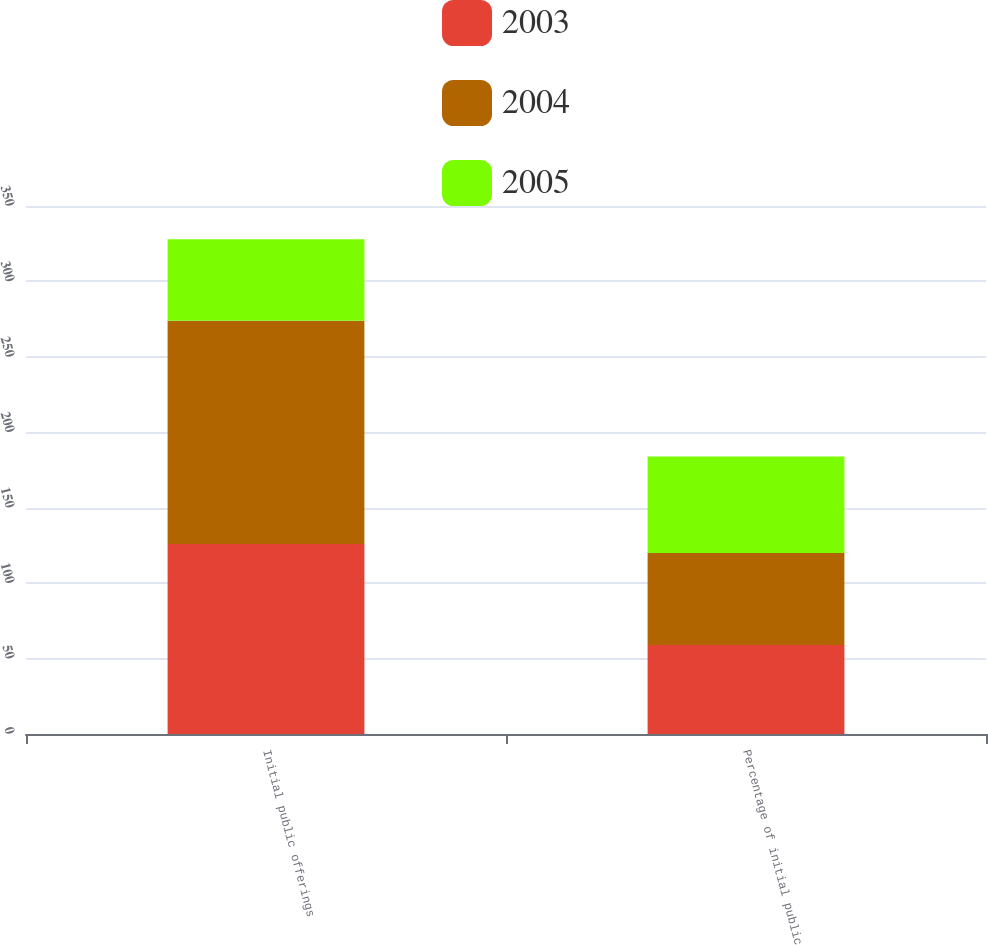<chart> <loc_0><loc_0><loc_500><loc_500><stacked_bar_chart><ecel><fcel>Initial public offerings<fcel>Percentage of initial public<nl><fcel>2003<fcel>126<fcel>59<nl><fcel>2004<fcel>148<fcel>61<nl><fcel>2005<fcel>54<fcel>64<nl></chart> 